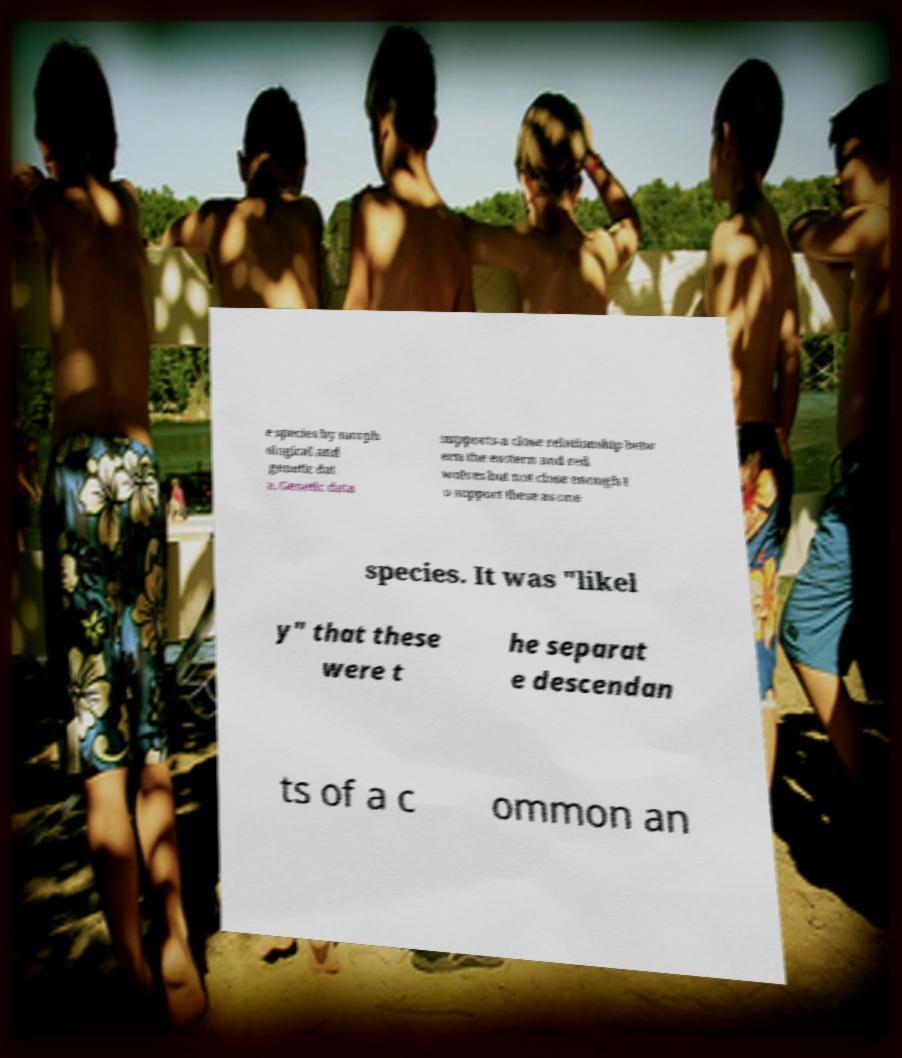Could you assist in decoding the text presented in this image and type it out clearly? e species by morph ological and genetic dat a. Genetic data supports a close relationship betw een the eastern and red wolves but not close enough t o support these as one species. It was "likel y" that these were t he separat e descendan ts of a c ommon an 